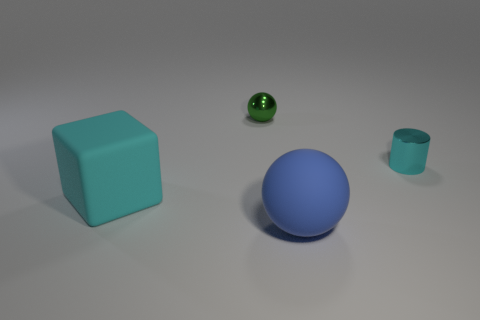What size is the blue object that is the same shape as the tiny green object?
Provide a succinct answer. Large. Is there anything else that is the same size as the metal ball?
Offer a very short reply. Yes. Do the tiny thing left of the blue rubber object and the small cylinder have the same material?
Offer a terse response. Yes. What is the color of the other rubber object that is the same shape as the green object?
Provide a short and direct response. Blue. How many other objects are there of the same color as the large cube?
Offer a terse response. 1. There is a metal thing that is behind the cylinder; is it the same shape as the cyan thing that is left of the small shiny cylinder?
Provide a short and direct response. No. How many blocks are big cyan rubber things or small cyan metal objects?
Provide a short and direct response. 1. Is the number of small shiny cylinders behind the small shiny cylinder less than the number of cyan matte blocks?
Provide a short and direct response. Yes. What number of other things are made of the same material as the blue sphere?
Ensure brevity in your answer.  1. Does the blue rubber thing have the same size as the metal sphere?
Your answer should be compact. No. 